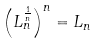Convert formula to latex. <formula><loc_0><loc_0><loc_500><loc_500>\left ( L _ { n } ^ { \frac { 1 } { n } } \right ) ^ { n } = L _ { n }</formula> 